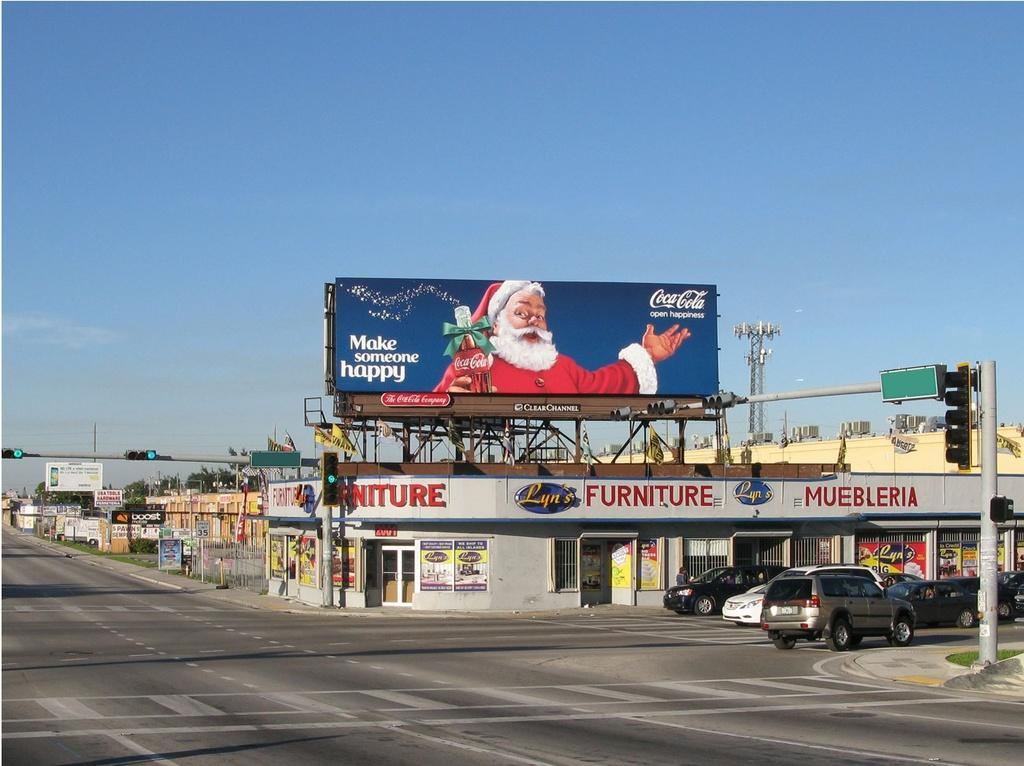<image>
Give a short and clear explanation of the subsequent image. an empty street with a Lyn's FURNITURE store and a Santa billboard above saying Make someone happy, and Coca Cola. 